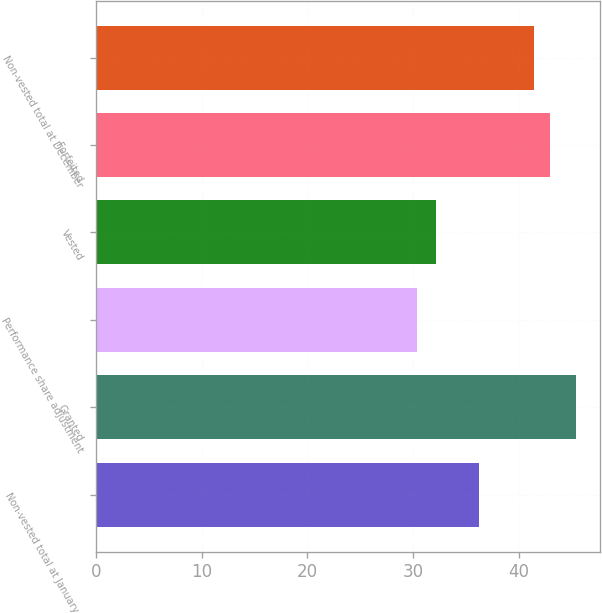<chart> <loc_0><loc_0><loc_500><loc_500><bar_chart><fcel>Non-vested total at January 1<fcel>Granted<fcel>Performance share adjustment<fcel>Vested<fcel>Forfeited<fcel>Non-vested total at December<nl><fcel>36.27<fcel>45.45<fcel>30.34<fcel>32.13<fcel>42.97<fcel>41.46<nl></chart> 